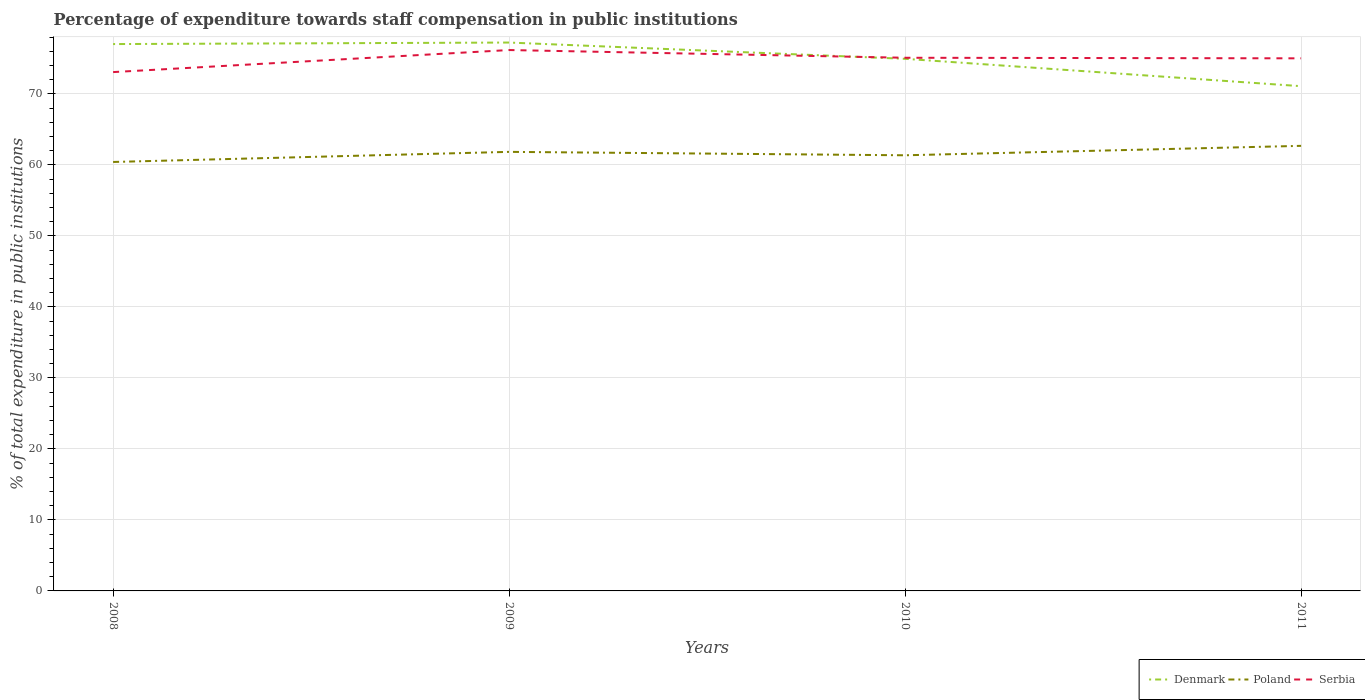How many different coloured lines are there?
Your answer should be very brief. 3. Does the line corresponding to Serbia intersect with the line corresponding to Denmark?
Provide a short and direct response. Yes. Across all years, what is the maximum percentage of expenditure towards staff compensation in Serbia?
Give a very brief answer. 73.07. What is the total percentage of expenditure towards staff compensation in Serbia in the graph?
Make the answer very short. -1.94. What is the difference between the highest and the second highest percentage of expenditure towards staff compensation in Serbia?
Your answer should be very brief. 3.1. Are the values on the major ticks of Y-axis written in scientific E-notation?
Your answer should be compact. No. Where does the legend appear in the graph?
Keep it short and to the point. Bottom right. How are the legend labels stacked?
Your answer should be compact. Horizontal. What is the title of the graph?
Your answer should be very brief. Percentage of expenditure towards staff compensation in public institutions. Does "Zambia" appear as one of the legend labels in the graph?
Provide a succinct answer. No. What is the label or title of the Y-axis?
Ensure brevity in your answer.  % of total expenditure in public institutions. What is the % of total expenditure in public institutions in Denmark in 2008?
Give a very brief answer. 77.02. What is the % of total expenditure in public institutions of Poland in 2008?
Make the answer very short. 60.41. What is the % of total expenditure in public institutions in Serbia in 2008?
Your response must be concise. 73.07. What is the % of total expenditure in public institutions of Denmark in 2009?
Keep it short and to the point. 77.23. What is the % of total expenditure in public institutions in Poland in 2009?
Your answer should be very brief. 61.84. What is the % of total expenditure in public institutions in Serbia in 2009?
Provide a short and direct response. 76.18. What is the % of total expenditure in public institutions of Denmark in 2010?
Make the answer very short. 74.94. What is the % of total expenditure in public institutions of Poland in 2010?
Your answer should be very brief. 61.35. What is the % of total expenditure in public institutions in Serbia in 2010?
Ensure brevity in your answer.  75.09. What is the % of total expenditure in public institutions in Denmark in 2011?
Ensure brevity in your answer.  71.09. What is the % of total expenditure in public institutions in Poland in 2011?
Provide a short and direct response. 62.68. What is the % of total expenditure in public institutions in Serbia in 2011?
Provide a succinct answer. 75.01. Across all years, what is the maximum % of total expenditure in public institutions in Denmark?
Provide a short and direct response. 77.23. Across all years, what is the maximum % of total expenditure in public institutions of Poland?
Provide a succinct answer. 62.68. Across all years, what is the maximum % of total expenditure in public institutions of Serbia?
Your response must be concise. 76.18. Across all years, what is the minimum % of total expenditure in public institutions in Denmark?
Give a very brief answer. 71.09. Across all years, what is the minimum % of total expenditure in public institutions of Poland?
Provide a short and direct response. 60.41. Across all years, what is the minimum % of total expenditure in public institutions of Serbia?
Ensure brevity in your answer.  73.07. What is the total % of total expenditure in public institutions of Denmark in the graph?
Keep it short and to the point. 300.28. What is the total % of total expenditure in public institutions in Poland in the graph?
Offer a terse response. 246.29. What is the total % of total expenditure in public institutions of Serbia in the graph?
Give a very brief answer. 299.34. What is the difference between the % of total expenditure in public institutions in Denmark in 2008 and that in 2009?
Your answer should be compact. -0.21. What is the difference between the % of total expenditure in public institutions in Poland in 2008 and that in 2009?
Offer a terse response. -1.42. What is the difference between the % of total expenditure in public institutions in Serbia in 2008 and that in 2009?
Give a very brief answer. -3.1. What is the difference between the % of total expenditure in public institutions in Denmark in 2008 and that in 2010?
Give a very brief answer. 2.08. What is the difference between the % of total expenditure in public institutions of Poland in 2008 and that in 2010?
Make the answer very short. -0.94. What is the difference between the % of total expenditure in public institutions of Serbia in 2008 and that in 2010?
Your response must be concise. -2.02. What is the difference between the % of total expenditure in public institutions of Denmark in 2008 and that in 2011?
Make the answer very short. 5.93. What is the difference between the % of total expenditure in public institutions in Poland in 2008 and that in 2011?
Make the answer very short. -2.27. What is the difference between the % of total expenditure in public institutions of Serbia in 2008 and that in 2011?
Provide a short and direct response. -1.94. What is the difference between the % of total expenditure in public institutions of Denmark in 2009 and that in 2010?
Provide a short and direct response. 2.29. What is the difference between the % of total expenditure in public institutions of Poland in 2009 and that in 2010?
Your answer should be compact. 0.48. What is the difference between the % of total expenditure in public institutions of Serbia in 2009 and that in 2010?
Offer a terse response. 1.09. What is the difference between the % of total expenditure in public institutions of Denmark in 2009 and that in 2011?
Your answer should be compact. 6.15. What is the difference between the % of total expenditure in public institutions of Poland in 2009 and that in 2011?
Ensure brevity in your answer.  -0.85. What is the difference between the % of total expenditure in public institutions of Serbia in 2009 and that in 2011?
Provide a succinct answer. 1.17. What is the difference between the % of total expenditure in public institutions in Denmark in 2010 and that in 2011?
Offer a very short reply. 3.85. What is the difference between the % of total expenditure in public institutions of Poland in 2010 and that in 2011?
Make the answer very short. -1.33. What is the difference between the % of total expenditure in public institutions in Serbia in 2010 and that in 2011?
Offer a very short reply. 0.08. What is the difference between the % of total expenditure in public institutions of Denmark in 2008 and the % of total expenditure in public institutions of Poland in 2009?
Your response must be concise. 15.18. What is the difference between the % of total expenditure in public institutions of Denmark in 2008 and the % of total expenditure in public institutions of Serbia in 2009?
Your response must be concise. 0.84. What is the difference between the % of total expenditure in public institutions in Poland in 2008 and the % of total expenditure in public institutions in Serbia in 2009?
Your answer should be very brief. -15.76. What is the difference between the % of total expenditure in public institutions of Denmark in 2008 and the % of total expenditure in public institutions of Poland in 2010?
Ensure brevity in your answer.  15.66. What is the difference between the % of total expenditure in public institutions of Denmark in 2008 and the % of total expenditure in public institutions of Serbia in 2010?
Your answer should be compact. 1.93. What is the difference between the % of total expenditure in public institutions of Poland in 2008 and the % of total expenditure in public institutions of Serbia in 2010?
Ensure brevity in your answer.  -14.68. What is the difference between the % of total expenditure in public institutions of Denmark in 2008 and the % of total expenditure in public institutions of Poland in 2011?
Your answer should be compact. 14.33. What is the difference between the % of total expenditure in public institutions in Denmark in 2008 and the % of total expenditure in public institutions in Serbia in 2011?
Your answer should be very brief. 2.01. What is the difference between the % of total expenditure in public institutions in Poland in 2008 and the % of total expenditure in public institutions in Serbia in 2011?
Your answer should be compact. -14.6. What is the difference between the % of total expenditure in public institutions of Denmark in 2009 and the % of total expenditure in public institutions of Poland in 2010?
Your response must be concise. 15.88. What is the difference between the % of total expenditure in public institutions in Denmark in 2009 and the % of total expenditure in public institutions in Serbia in 2010?
Provide a short and direct response. 2.14. What is the difference between the % of total expenditure in public institutions in Poland in 2009 and the % of total expenditure in public institutions in Serbia in 2010?
Give a very brief answer. -13.25. What is the difference between the % of total expenditure in public institutions in Denmark in 2009 and the % of total expenditure in public institutions in Poland in 2011?
Offer a very short reply. 14.55. What is the difference between the % of total expenditure in public institutions in Denmark in 2009 and the % of total expenditure in public institutions in Serbia in 2011?
Ensure brevity in your answer.  2.22. What is the difference between the % of total expenditure in public institutions in Poland in 2009 and the % of total expenditure in public institutions in Serbia in 2011?
Your response must be concise. -13.17. What is the difference between the % of total expenditure in public institutions in Denmark in 2010 and the % of total expenditure in public institutions in Poland in 2011?
Offer a terse response. 12.26. What is the difference between the % of total expenditure in public institutions of Denmark in 2010 and the % of total expenditure in public institutions of Serbia in 2011?
Provide a succinct answer. -0.07. What is the difference between the % of total expenditure in public institutions of Poland in 2010 and the % of total expenditure in public institutions of Serbia in 2011?
Give a very brief answer. -13.65. What is the average % of total expenditure in public institutions of Denmark per year?
Make the answer very short. 75.07. What is the average % of total expenditure in public institutions of Poland per year?
Offer a very short reply. 61.57. What is the average % of total expenditure in public institutions of Serbia per year?
Offer a terse response. 74.84. In the year 2008, what is the difference between the % of total expenditure in public institutions in Denmark and % of total expenditure in public institutions in Poland?
Provide a succinct answer. 16.61. In the year 2008, what is the difference between the % of total expenditure in public institutions of Denmark and % of total expenditure in public institutions of Serbia?
Offer a very short reply. 3.95. In the year 2008, what is the difference between the % of total expenditure in public institutions of Poland and % of total expenditure in public institutions of Serbia?
Give a very brief answer. -12.66. In the year 2009, what is the difference between the % of total expenditure in public institutions of Denmark and % of total expenditure in public institutions of Poland?
Your answer should be very brief. 15.4. In the year 2009, what is the difference between the % of total expenditure in public institutions of Denmark and % of total expenditure in public institutions of Serbia?
Make the answer very short. 1.06. In the year 2009, what is the difference between the % of total expenditure in public institutions of Poland and % of total expenditure in public institutions of Serbia?
Your answer should be compact. -14.34. In the year 2010, what is the difference between the % of total expenditure in public institutions in Denmark and % of total expenditure in public institutions in Poland?
Offer a very short reply. 13.59. In the year 2010, what is the difference between the % of total expenditure in public institutions in Denmark and % of total expenditure in public institutions in Serbia?
Your answer should be compact. -0.15. In the year 2010, what is the difference between the % of total expenditure in public institutions in Poland and % of total expenditure in public institutions in Serbia?
Give a very brief answer. -13.73. In the year 2011, what is the difference between the % of total expenditure in public institutions in Denmark and % of total expenditure in public institutions in Poland?
Make the answer very short. 8.4. In the year 2011, what is the difference between the % of total expenditure in public institutions in Denmark and % of total expenditure in public institutions in Serbia?
Give a very brief answer. -3.92. In the year 2011, what is the difference between the % of total expenditure in public institutions in Poland and % of total expenditure in public institutions in Serbia?
Provide a succinct answer. -12.32. What is the ratio of the % of total expenditure in public institutions in Denmark in 2008 to that in 2009?
Keep it short and to the point. 1. What is the ratio of the % of total expenditure in public institutions of Serbia in 2008 to that in 2009?
Keep it short and to the point. 0.96. What is the ratio of the % of total expenditure in public institutions of Denmark in 2008 to that in 2010?
Keep it short and to the point. 1.03. What is the ratio of the % of total expenditure in public institutions in Poland in 2008 to that in 2010?
Make the answer very short. 0.98. What is the ratio of the % of total expenditure in public institutions of Serbia in 2008 to that in 2010?
Keep it short and to the point. 0.97. What is the ratio of the % of total expenditure in public institutions of Denmark in 2008 to that in 2011?
Provide a succinct answer. 1.08. What is the ratio of the % of total expenditure in public institutions of Poland in 2008 to that in 2011?
Your response must be concise. 0.96. What is the ratio of the % of total expenditure in public institutions of Serbia in 2008 to that in 2011?
Make the answer very short. 0.97. What is the ratio of the % of total expenditure in public institutions in Denmark in 2009 to that in 2010?
Provide a short and direct response. 1.03. What is the ratio of the % of total expenditure in public institutions in Poland in 2009 to that in 2010?
Keep it short and to the point. 1.01. What is the ratio of the % of total expenditure in public institutions of Serbia in 2009 to that in 2010?
Provide a short and direct response. 1.01. What is the ratio of the % of total expenditure in public institutions in Denmark in 2009 to that in 2011?
Offer a very short reply. 1.09. What is the ratio of the % of total expenditure in public institutions of Poland in 2009 to that in 2011?
Your answer should be very brief. 0.99. What is the ratio of the % of total expenditure in public institutions of Serbia in 2009 to that in 2011?
Give a very brief answer. 1.02. What is the ratio of the % of total expenditure in public institutions in Denmark in 2010 to that in 2011?
Make the answer very short. 1.05. What is the ratio of the % of total expenditure in public institutions of Poland in 2010 to that in 2011?
Your response must be concise. 0.98. What is the ratio of the % of total expenditure in public institutions in Serbia in 2010 to that in 2011?
Offer a very short reply. 1. What is the difference between the highest and the second highest % of total expenditure in public institutions of Denmark?
Keep it short and to the point. 0.21. What is the difference between the highest and the second highest % of total expenditure in public institutions of Poland?
Offer a very short reply. 0.85. What is the difference between the highest and the second highest % of total expenditure in public institutions of Serbia?
Offer a very short reply. 1.09. What is the difference between the highest and the lowest % of total expenditure in public institutions of Denmark?
Give a very brief answer. 6.15. What is the difference between the highest and the lowest % of total expenditure in public institutions in Poland?
Make the answer very short. 2.27. What is the difference between the highest and the lowest % of total expenditure in public institutions in Serbia?
Your answer should be very brief. 3.1. 